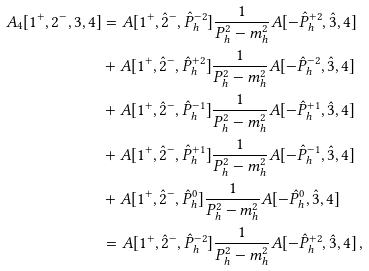<formula> <loc_0><loc_0><loc_500><loc_500>A _ { 4 } [ 1 ^ { + } , 2 ^ { - } , 3 , 4 ] & = A [ 1 ^ { + } , \hat { 2 } ^ { - } , \hat { P } _ { h } ^ { - 2 } ] \frac { 1 } { P _ { h } ^ { 2 } - m _ { h } ^ { 2 } } A [ - \hat { P } _ { h } ^ { + 2 } , \hat { 3 } , 4 ] \\ & + A [ 1 ^ { + } , \hat { 2 } ^ { - } , \hat { P } _ { h } ^ { + 2 } ] \frac { 1 } { P _ { h } ^ { 2 } - m _ { h } ^ { 2 } } A [ - \hat { P } _ { h } ^ { - 2 } , \hat { 3 } , 4 ] \\ & + A [ 1 ^ { + } , \hat { 2 } ^ { - } , \hat { P } _ { h } ^ { - 1 } ] \frac { 1 } { P _ { h } ^ { 2 } - m _ { h } ^ { 2 } } A [ - \hat { P } _ { h } ^ { + 1 } , \hat { 3 } , 4 ] \\ & + A [ 1 ^ { + } , \hat { 2 } ^ { - } , \hat { P } _ { h } ^ { + 1 } ] \frac { 1 } { P _ { h } ^ { 2 } - m _ { h } ^ { 2 } } A [ - \hat { P } _ { h } ^ { - 1 } , \hat { 3 } , 4 ] \\ & + A [ 1 ^ { + } , \hat { 2 } ^ { - } , \hat { P } _ { h } ^ { 0 } ] \frac { 1 } { P _ { h } ^ { 2 } - m _ { h } ^ { 2 } } A [ - \hat { P } _ { h } ^ { 0 } , \hat { 3 } , 4 ] \\ & = A [ 1 ^ { + } , \hat { 2 } ^ { - } , \hat { P } _ { h } ^ { - 2 } ] \frac { 1 } { P _ { h } ^ { 2 } - m _ { h } ^ { 2 } } A [ - \hat { P } _ { h } ^ { + 2 } , \hat { 3 } , 4 ] \, ,</formula> 